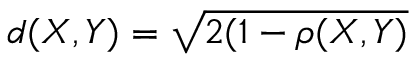Convert formula to latex. <formula><loc_0><loc_0><loc_500><loc_500>d ( X , Y ) = \sqrt { 2 ( 1 - \rho ( X , Y ) }</formula> 